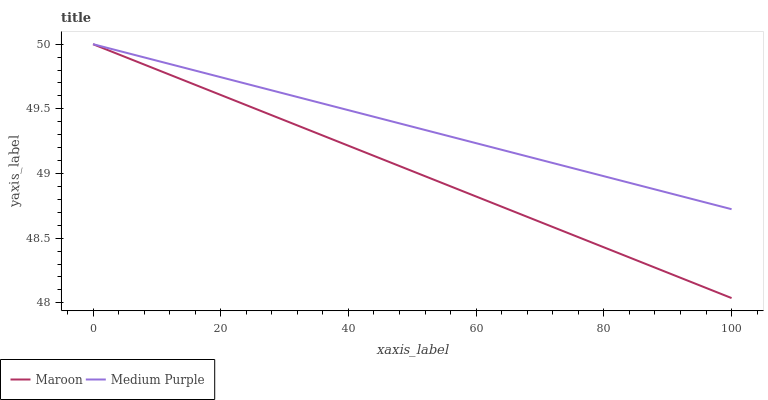Does Maroon have the minimum area under the curve?
Answer yes or no. Yes. Does Medium Purple have the maximum area under the curve?
Answer yes or no. Yes. Does Maroon have the maximum area under the curve?
Answer yes or no. No. Is Maroon the smoothest?
Answer yes or no. Yes. Is Medium Purple the roughest?
Answer yes or no. Yes. Is Maroon the roughest?
Answer yes or no. No. Does Maroon have the lowest value?
Answer yes or no. Yes. Does Maroon have the highest value?
Answer yes or no. Yes. Does Medium Purple intersect Maroon?
Answer yes or no. Yes. Is Medium Purple less than Maroon?
Answer yes or no. No. Is Medium Purple greater than Maroon?
Answer yes or no. No. 